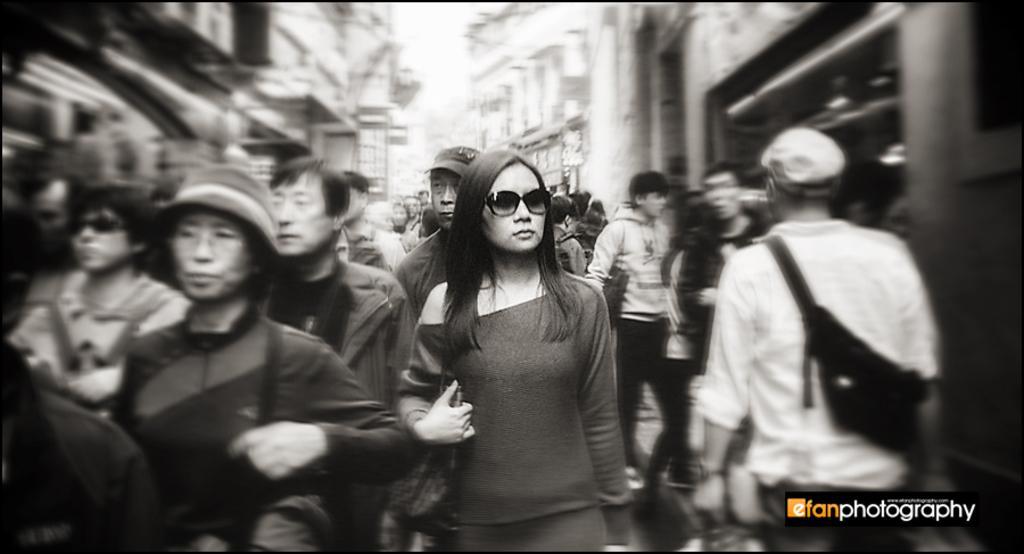Describe this image in one or two sentences. This is a black and white picture. Here we can see few persons. In the background there are buildings. 